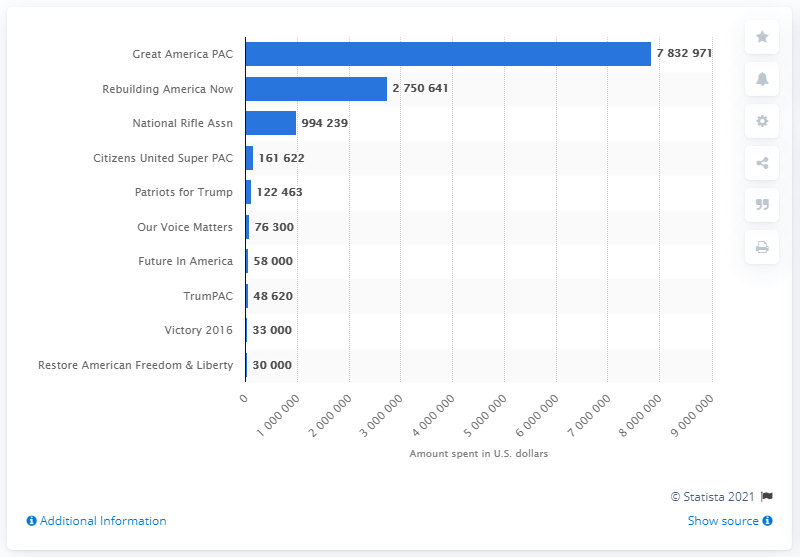Identify some key points in this picture. The Great America PAC spent a total of $7,832,971 in August 2016. 